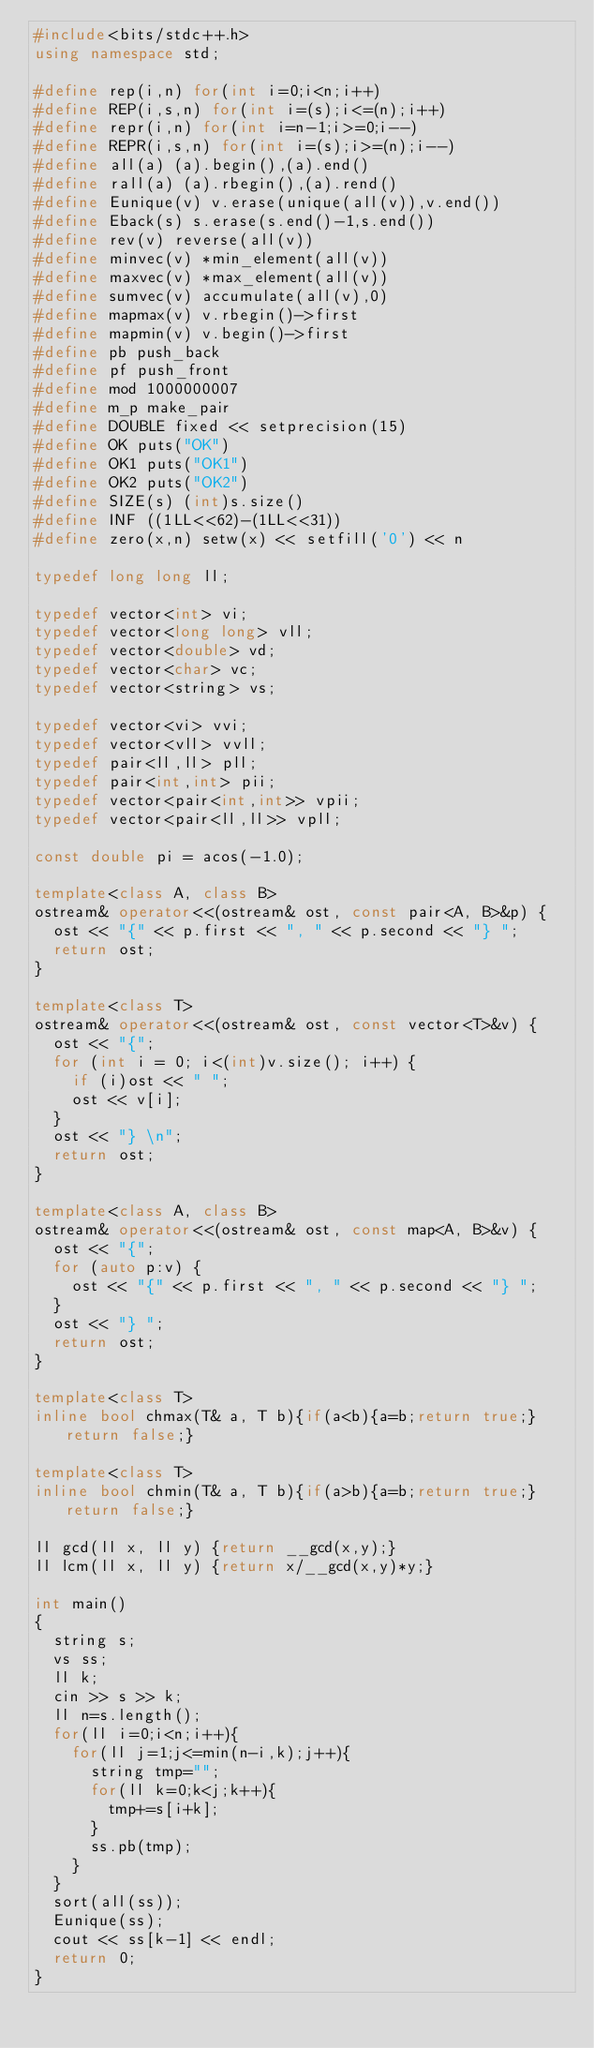Convert code to text. <code><loc_0><loc_0><loc_500><loc_500><_C++_>#include<bits/stdc++.h>
using namespace std;

#define rep(i,n) for(int i=0;i<n;i++)
#define REP(i,s,n) for(int i=(s);i<=(n);i++)
#define repr(i,n) for(int i=n-1;i>=0;i--)
#define REPR(i,s,n) for(int i=(s);i>=(n);i--)
#define all(a) (a).begin(),(a).end()
#define rall(a) (a).rbegin(),(a).rend()
#define Eunique(v) v.erase(unique(all(v)),v.end())
#define Eback(s) s.erase(s.end()-1,s.end())
#define rev(v) reverse(all(v))
#define minvec(v) *min_element(all(v))
#define maxvec(v) *max_element(all(v))
#define sumvec(v) accumulate(all(v),0)
#define mapmax(v) v.rbegin()->first
#define mapmin(v) v.begin()->first
#define pb push_back
#define pf push_front
#define mod 1000000007
#define m_p make_pair
#define DOUBLE fixed << setprecision(15)
#define OK puts("OK")
#define OK1 puts("OK1")
#define OK2 puts("OK2")
#define SIZE(s) (int)s.size()
#define INF ((1LL<<62)-(1LL<<31))
#define zero(x,n) setw(x) << setfill('0') << n

typedef long long ll;

typedef vector<int> vi;
typedef vector<long long> vll;
typedef vector<double> vd;
typedef vector<char> vc;
typedef vector<string> vs;

typedef vector<vi> vvi;
typedef vector<vll> vvll;
typedef pair<ll,ll> pll;
typedef pair<int,int> pii;
typedef vector<pair<int,int>> vpii;
typedef vector<pair<ll,ll>> vpll;

const double pi = acos(-1.0);

template<class A, class B>
ostream& operator<<(ostream& ost, const pair<A, B>&p) {
	ost << "{" << p.first << ", " << p.second << "} ";
	return ost;
}

template<class T>
ostream& operator<<(ostream& ost, const vector<T>&v) {
	ost << "{";
	for (int i = 0; i<(int)v.size(); i++) {
		if (i)ost << " ";
		ost << v[i];
	}
	ost << "} \n";
	return ost;
}

template<class A, class B>
ostream& operator<<(ostream& ost, const map<A, B>&v) {
	ost << "{";
	for (auto p:v) {
		ost << "{" << p.first << ", " << p.second << "} ";
	}
	ost << "} ";
	return ost;
}

template<class T>
inline bool chmax(T& a, T b){if(a<b){a=b;return true;} return false;}

template<class T>
inline bool chmin(T& a, T b){if(a>b){a=b;return true;} return false;}

ll gcd(ll x, ll y) {return __gcd(x,y);}
ll lcm(ll x, ll y) {return x/__gcd(x,y)*y;}

int main()
{
	string s;
	vs ss;
	ll k;
	cin >> s >> k;
	ll n=s.length();
	for(ll i=0;i<n;i++){
		for(ll j=1;j<=min(n-i,k);j++){
			string tmp="";
			for(ll k=0;k<j;k++){
				tmp+=s[i+k];
			}
			ss.pb(tmp);
		}
	}
	sort(all(ss));
	Eunique(ss);
	cout << ss[k-1] << endl;
	return 0;
}
</code> 